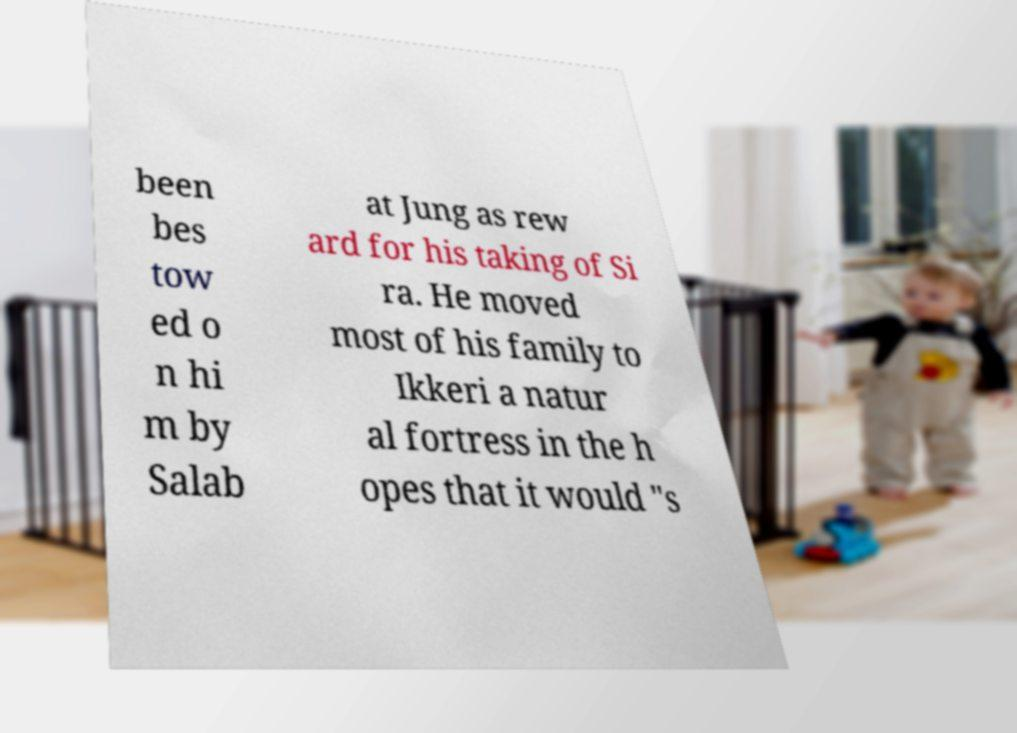Please read and relay the text visible in this image. What does it say? been bes tow ed o n hi m by Salab at Jung as rew ard for his taking of Si ra. He moved most of his family to Ikkeri a natur al fortress in the h opes that it would "s 